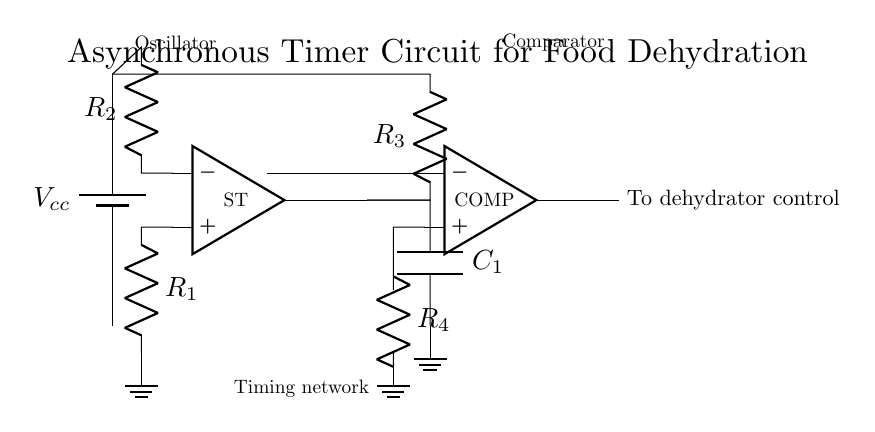What is the purpose of the Schmitt trigger? The Schmitt trigger acts as an oscillator in the circuit, helping to provide a stable transition between high and low states (i.e., on and off) based on the input voltage levels. This ensures that the timing network operates correctly to control the dehydration process effectively.
Answer: Oscillator What does the capacitor in the timing network do? The capacitor, denoted as C1, is part of the timing network and impacts the frequency of the oscillation by charging and discharging. Its value determines the duration of the drying cycle by controlling how quickly the voltage changes across it, which in turn affects the output timing for the dehydrator.
Answer: Duration control How many resistors are present in this circuit? The circuit diagram shows four resistors identified as R1, R2, R3, and R4. Each of these resistors plays a role in setting the voltage levels and timing characteristics of the circuit.
Answer: Four What is the output of the comparator connected to? The output of the comparator is connected to the dehydrator control mechanism, which allows it to turn the dehydrator on or off based on the timing established by the preceding components in the circuit.
Answer: Dehydrator control How does the configuration of R3 and C1 influence the timing? The configuration of R3 in series with capacitor C1 forms an RC timing network, which determines the time constant of the circuit. The time constant, calculated as the product of resistance and capacitance, affects how fast the output signal toggles, thus directly influencing the duration of the drying process.
Answer: Time constant What is the significance of the label "ST"? The label "ST" represents the Schmitt trigger in the circuit, indicating that it is a key component responsible for generating the oscillating signal required for the timer function. It distinguishes this component from others like the comparator and resistors in the circuit.
Answer: Schmitt trigger What component is used for energy storage in this circuit? The capacitor C1 serves as the energy storage component, allowing it to store and release electrical energy, which is essential for creating the timing pulse necessary for controlling the dehydrator operation based on the circuit design.
Answer: Capacitor 